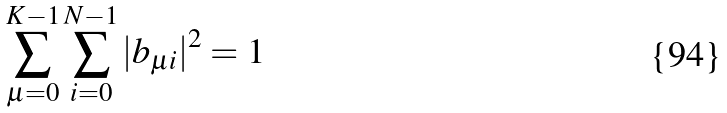<formula> <loc_0><loc_0><loc_500><loc_500>\sum _ { \mu = 0 } ^ { K - 1 } \sum _ { i = 0 } ^ { N - 1 } { | b _ { \mu i } | } ^ { 2 } = 1</formula> 